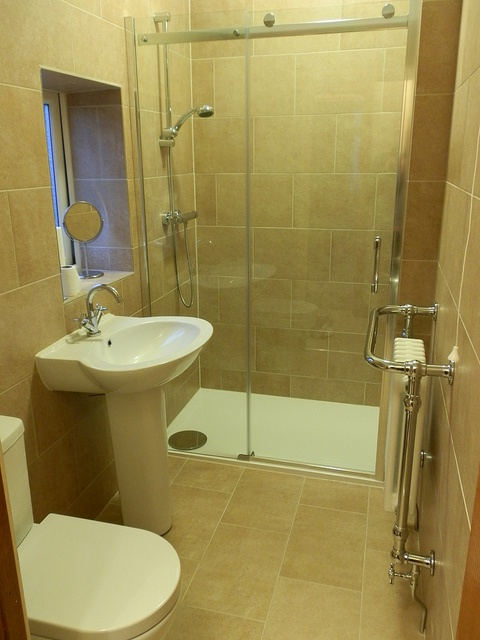Describe the objects in this image and their specific colors. I can see toilet in tan and khaki tones and sink in tan, beige, and olive tones in this image. 